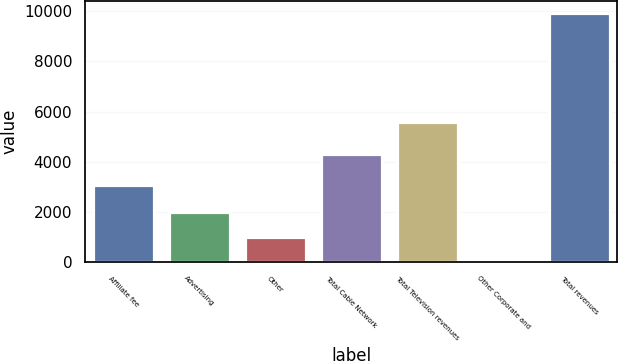Convert chart to OTSL. <chart><loc_0><loc_0><loc_500><loc_500><bar_chart><fcel>Affiliate fee<fcel>Advertising<fcel>Other<fcel>Total Cable Network<fcel>Total Television revenues<fcel>Other Corporate and<fcel>Total revenues<nl><fcel>3059<fcel>1985.8<fcel>993.9<fcel>4323<fcel>5600<fcel>2<fcel>9921<nl></chart> 